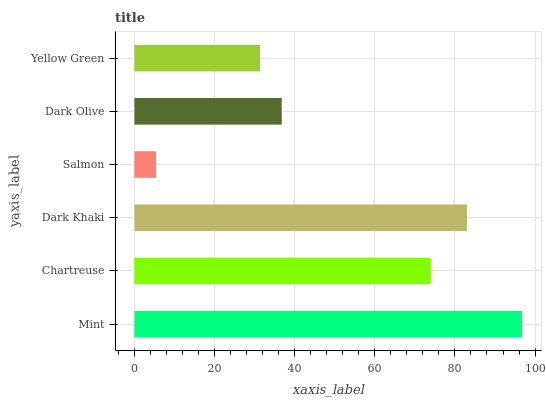Is Salmon the minimum?
Answer yes or no. Yes. Is Mint the maximum?
Answer yes or no. Yes. Is Chartreuse the minimum?
Answer yes or no. No. Is Chartreuse the maximum?
Answer yes or no. No. Is Mint greater than Chartreuse?
Answer yes or no. Yes. Is Chartreuse less than Mint?
Answer yes or no. Yes. Is Chartreuse greater than Mint?
Answer yes or no. No. Is Mint less than Chartreuse?
Answer yes or no. No. Is Chartreuse the high median?
Answer yes or no. Yes. Is Dark Olive the low median?
Answer yes or no. Yes. Is Salmon the high median?
Answer yes or no. No. Is Dark Khaki the low median?
Answer yes or no. No. 